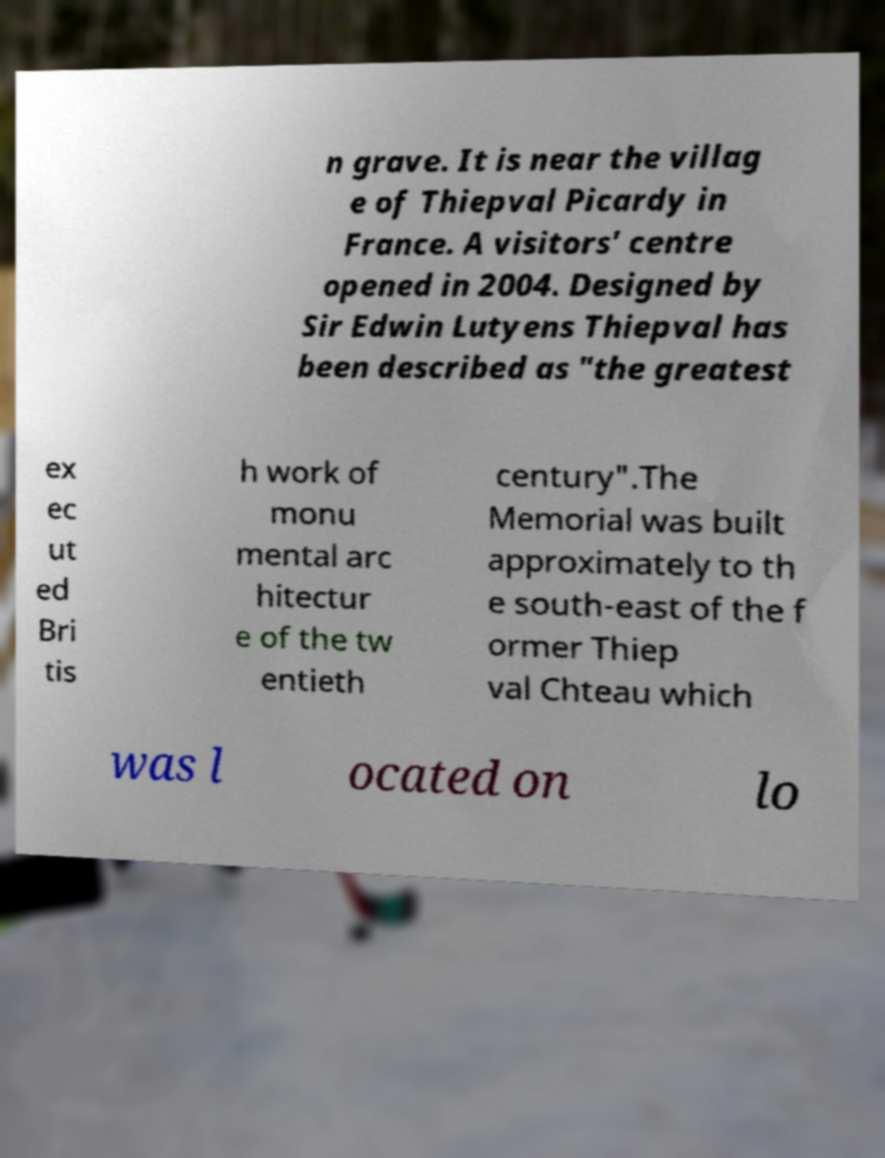Please identify and transcribe the text found in this image. n grave. It is near the villag e of Thiepval Picardy in France. A visitors' centre opened in 2004. Designed by Sir Edwin Lutyens Thiepval has been described as "the greatest ex ec ut ed Bri tis h work of monu mental arc hitectur e of the tw entieth century".The Memorial was built approximately to th e south-east of the f ormer Thiep val Chteau which was l ocated on lo 